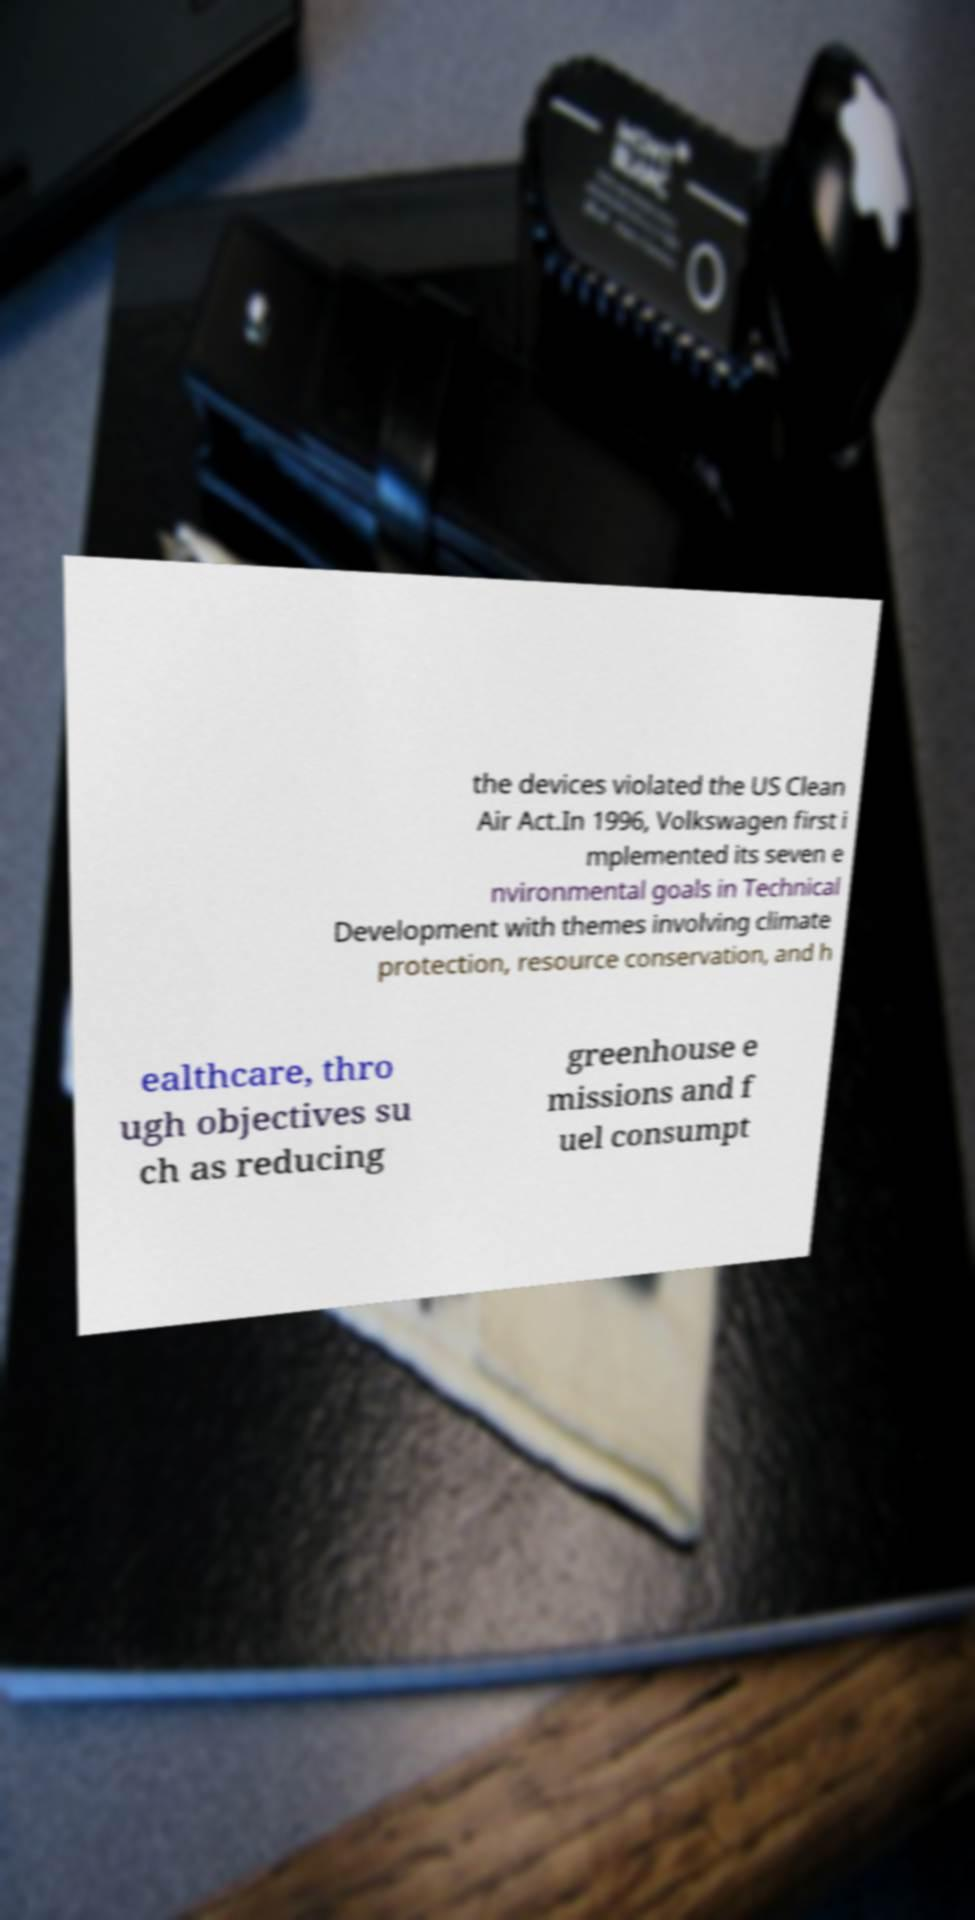Could you extract and type out the text from this image? the devices violated the US Clean Air Act.In 1996, Volkswagen first i mplemented its seven e nvironmental goals in Technical Development with themes involving climate protection, resource conservation, and h ealthcare, thro ugh objectives su ch as reducing greenhouse e missions and f uel consumpt 